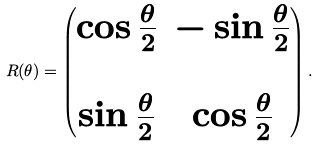<formula> <loc_0><loc_0><loc_500><loc_500>R ( \theta ) = \begin{pmatrix} \cos \frac { \theta } { 2 } & - \sin \frac { \theta } { 2 } \\ \\ \sin \frac { \theta } { 2 } & \cos \frac { \theta } { 2 } \end{pmatrix} .</formula> 